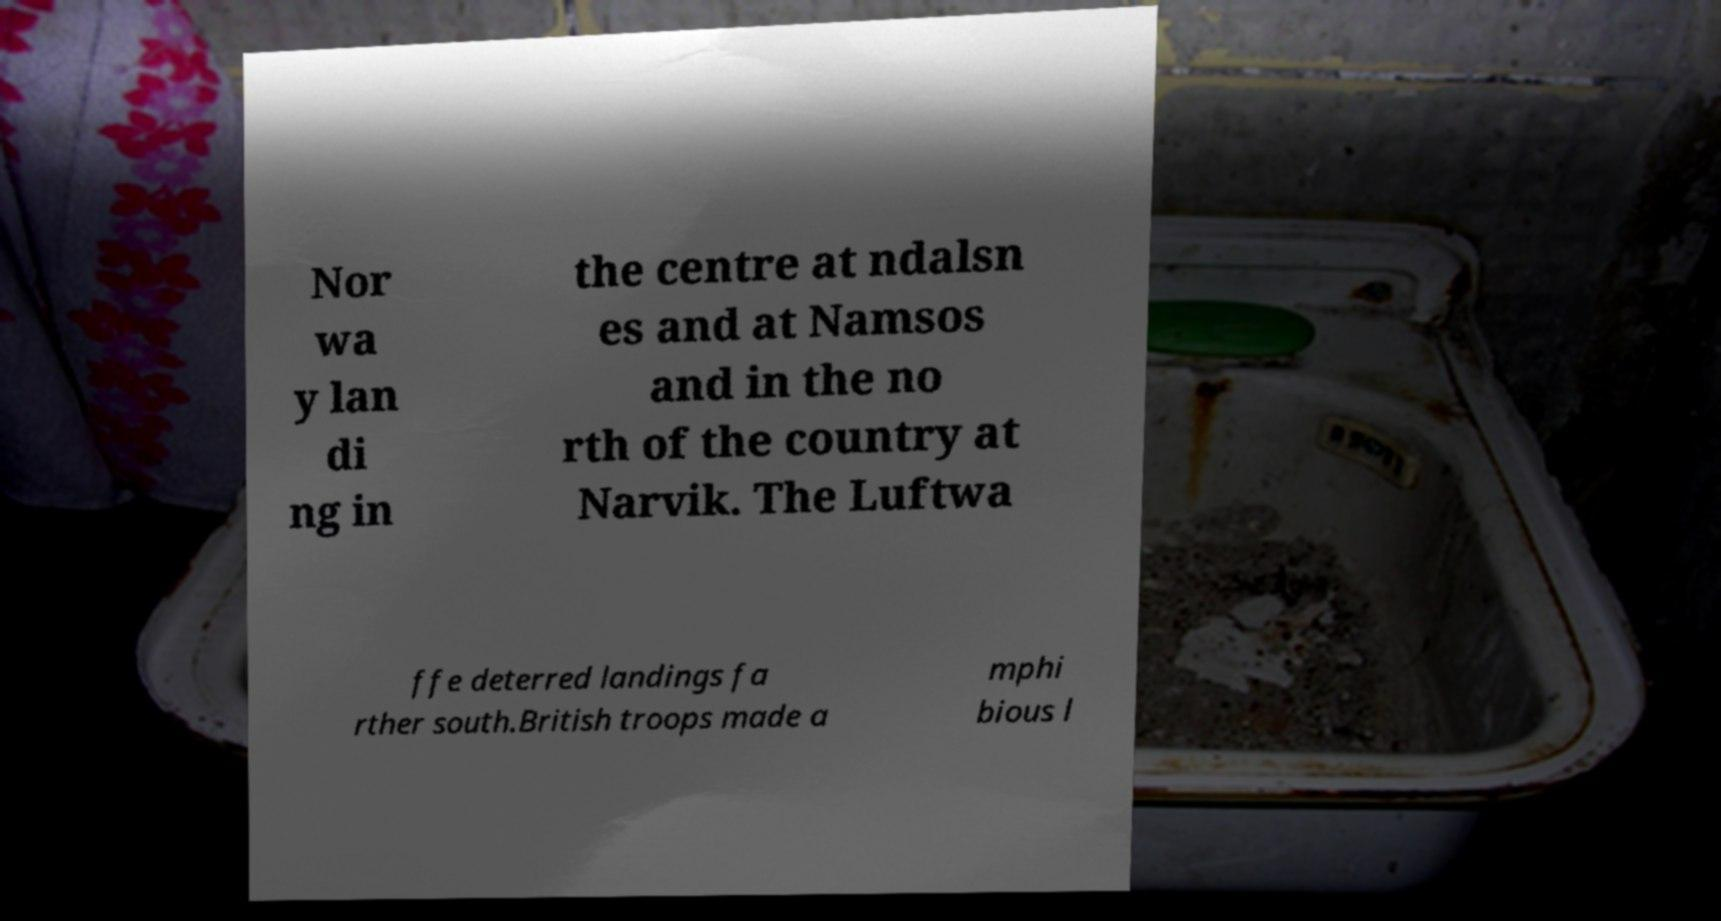Can you accurately transcribe the text from the provided image for me? Nor wa y lan di ng in the centre at ndalsn es and at Namsos and in the no rth of the country at Narvik. The Luftwa ffe deterred landings fa rther south.British troops made a mphi bious l 